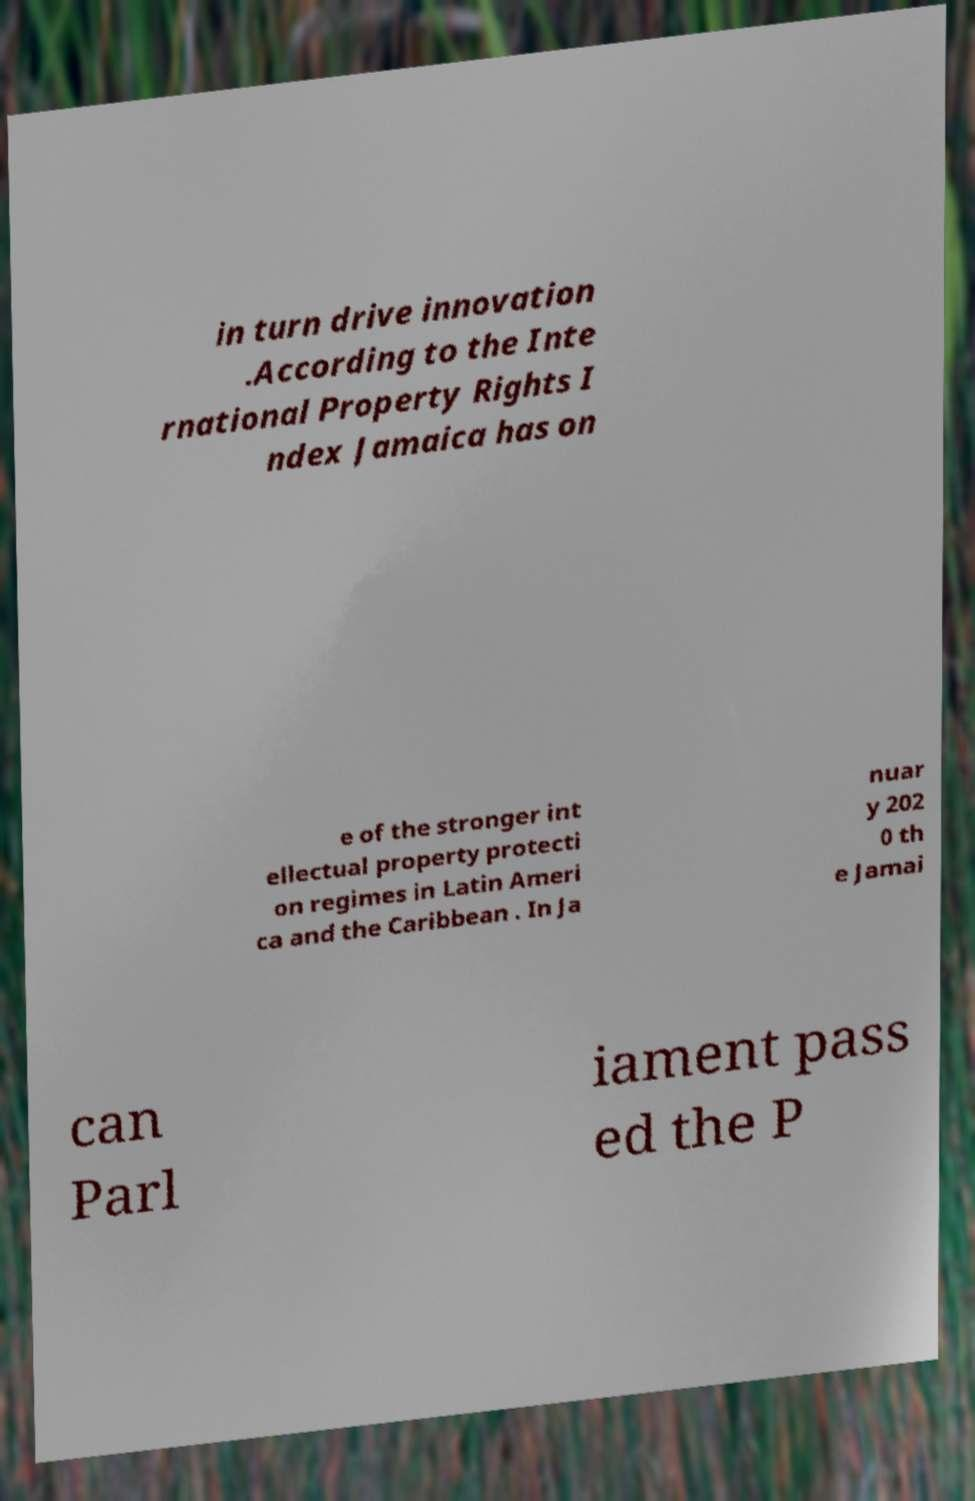Could you extract and type out the text from this image? in turn drive innovation .According to the Inte rnational Property Rights I ndex Jamaica has on e of the stronger int ellectual property protecti on regimes in Latin Ameri ca and the Caribbean . In Ja nuar y 202 0 th e Jamai can Parl iament pass ed the P 